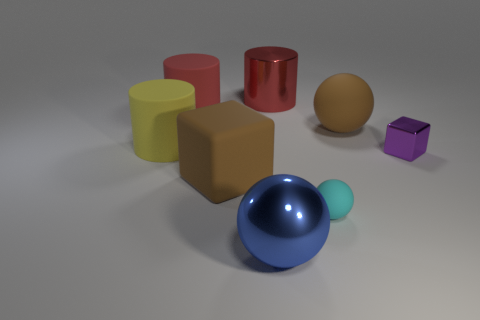Subtract all gray cylinders. Subtract all brown balls. How many cylinders are left? 3 Add 1 metal cubes. How many objects exist? 9 Subtract all cylinders. How many objects are left? 5 Add 2 small yellow metal balls. How many small yellow metal balls exist? 2 Subtract 0 green blocks. How many objects are left? 8 Subtract all red metallic cylinders. Subtract all metal cylinders. How many objects are left? 6 Add 8 large brown rubber blocks. How many large brown rubber blocks are left? 9 